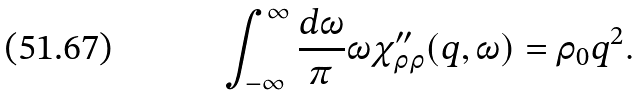Convert formula to latex. <formula><loc_0><loc_0><loc_500><loc_500>\int ^ { \infty } _ { - \infty } \frac { d \omega } { \pi } \omega \chi ^ { \prime \prime } _ { \rho \rho } ( { q } , \omega ) = \rho _ { 0 } q ^ { 2 } .</formula> 